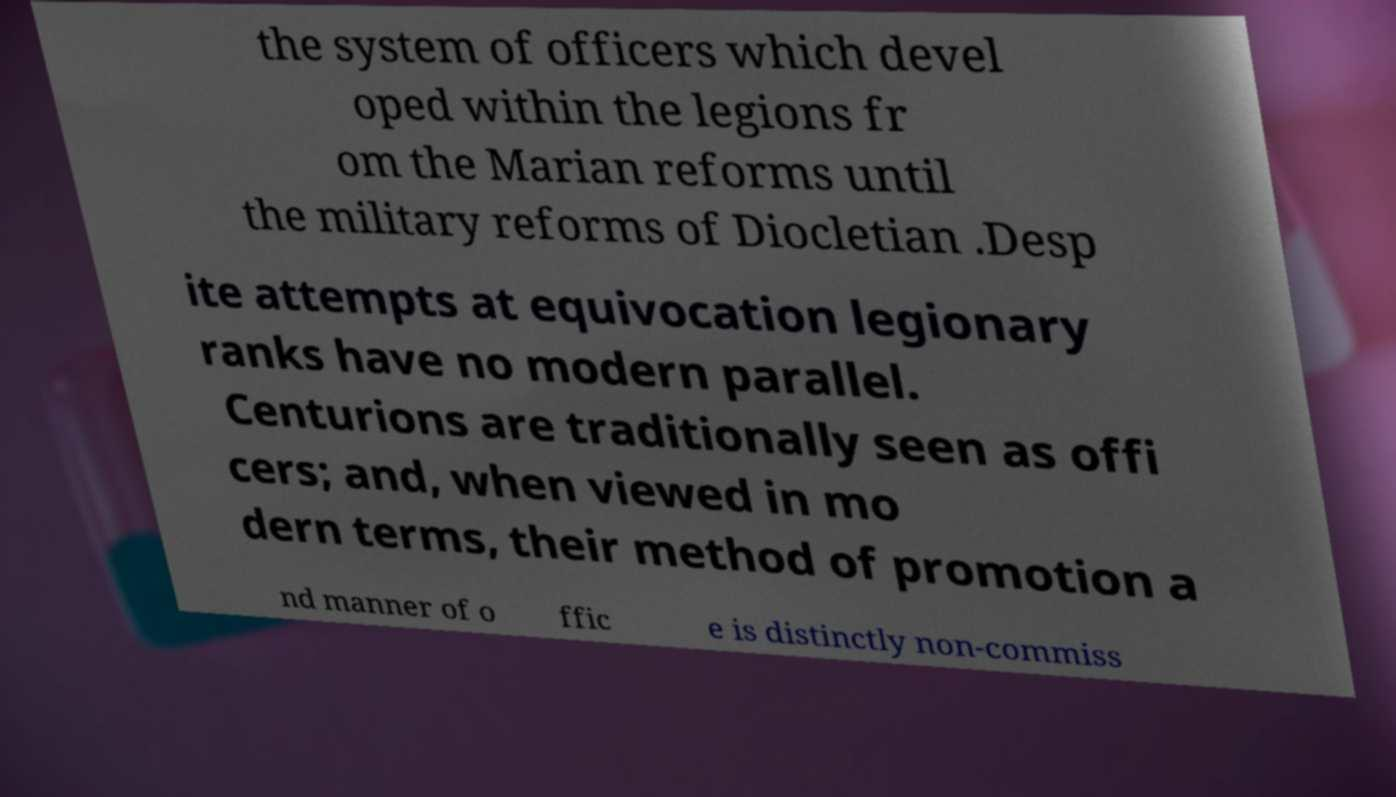Could you extract and type out the text from this image? the system of officers which devel oped within the legions fr om the Marian reforms until the military reforms of Diocletian .Desp ite attempts at equivocation legionary ranks have no modern parallel. Centurions are traditionally seen as offi cers; and, when viewed in mo dern terms, their method of promotion a nd manner of o ffic e is distinctly non-commiss 